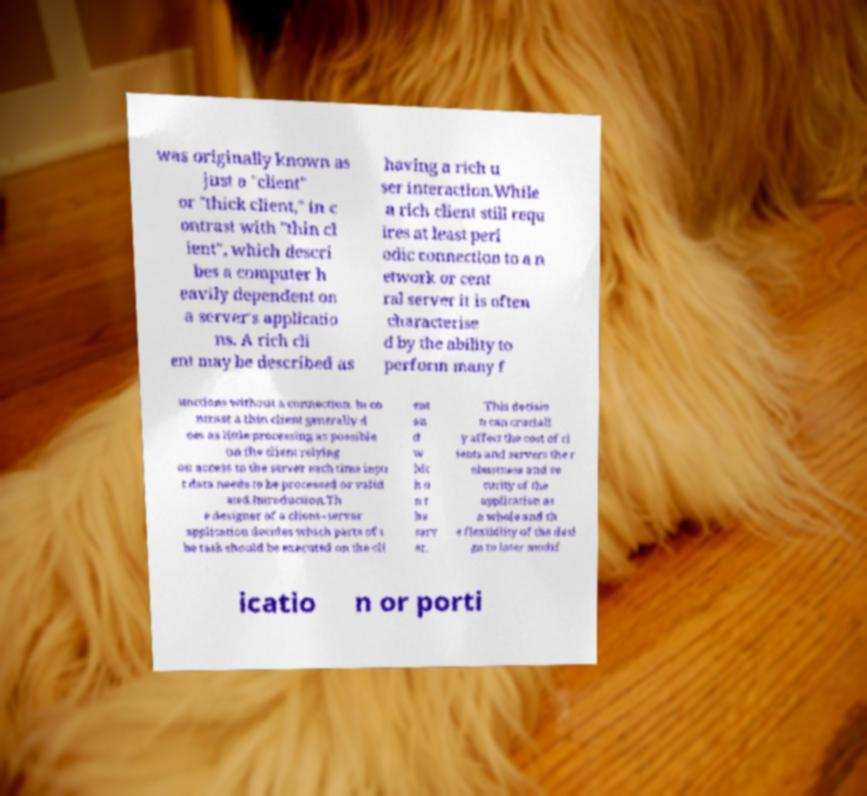Could you assist in decoding the text presented in this image and type it out clearly? was originally known as just a "client" or "thick client," in c ontrast with "thin cl ient", which descri bes a computer h eavily dependent on a server's applicatio ns. A rich cli ent may be described as having a rich u ser interaction.While a rich client still requ ires at least peri odic connection to a n etwork or cent ral server it is often characterise d by the ability to perform many f unctions without a connection. In co ntrast a thin client generally d oes as little processing as possible on the client relying on access to the server each time inpu t data needs to be processed or valid ated.Introduction.Th e designer of a client–server application decides which parts of t he task should be executed on the cli ent an d w hic h o n t he serv er. This decisio n can cruciall y affect the cost of cl ients and servers the r obustness and se curity of the application as a whole and th e flexibility of the desi gn to later modif icatio n or porti 